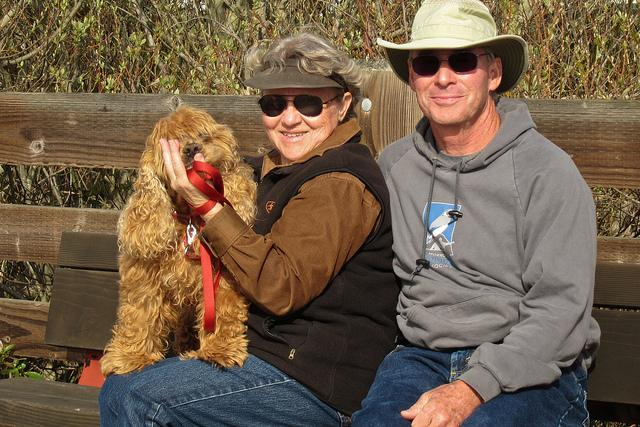What do both people have on?

Choices:
A) crowns
B) sunglasses
C) armor
D) masks sunglasses 